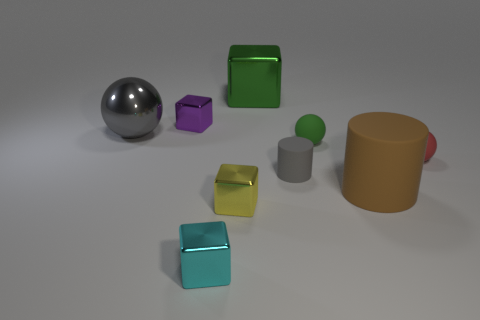Add 1 purple blocks. How many objects exist? 10 Subtract all blocks. How many objects are left? 5 Add 1 red balls. How many red balls exist? 2 Subtract 0 yellow spheres. How many objects are left? 9 Subtract all big metallic balls. Subtract all small red rubber objects. How many objects are left? 7 Add 1 small red rubber balls. How many small red rubber balls are left? 2 